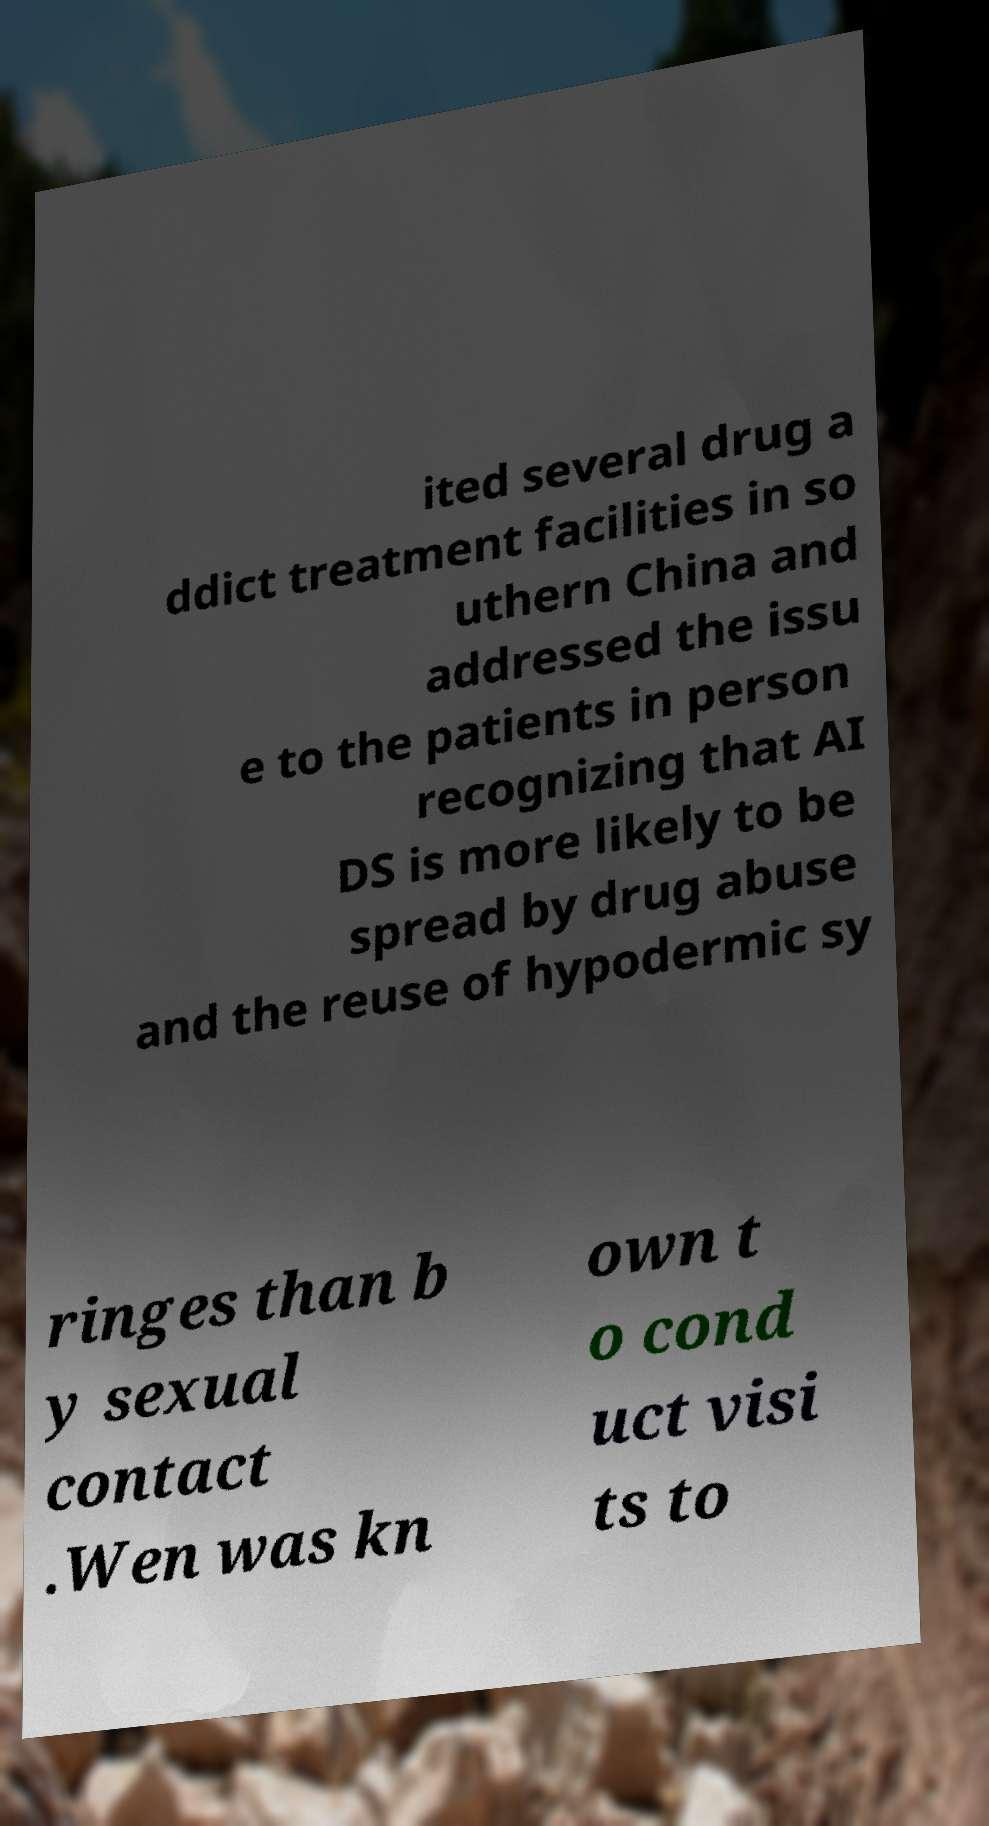Could you assist in decoding the text presented in this image and type it out clearly? ited several drug a ddict treatment facilities in so uthern China and addressed the issu e to the patients in person recognizing that AI DS is more likely to be spread by drug abuse and the reuse of hypodermic sy ringes than b y sexual contact .Wen was kn own t o cond uct visi ts to 